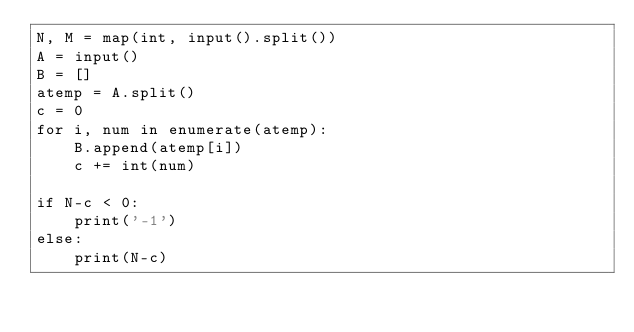<code> <loc_0><loc_0><loc_500><loc_500><_Python_>N, M = map(int, input().split())
A = input()
B = []
atemp = A.split()
c = 0
for i, num in enumerate(atemp):
    B.append(atemp[i])
    c += int(num)

if N-c < 0:
    print('-1')
else:
    print(N-c)
</code> 